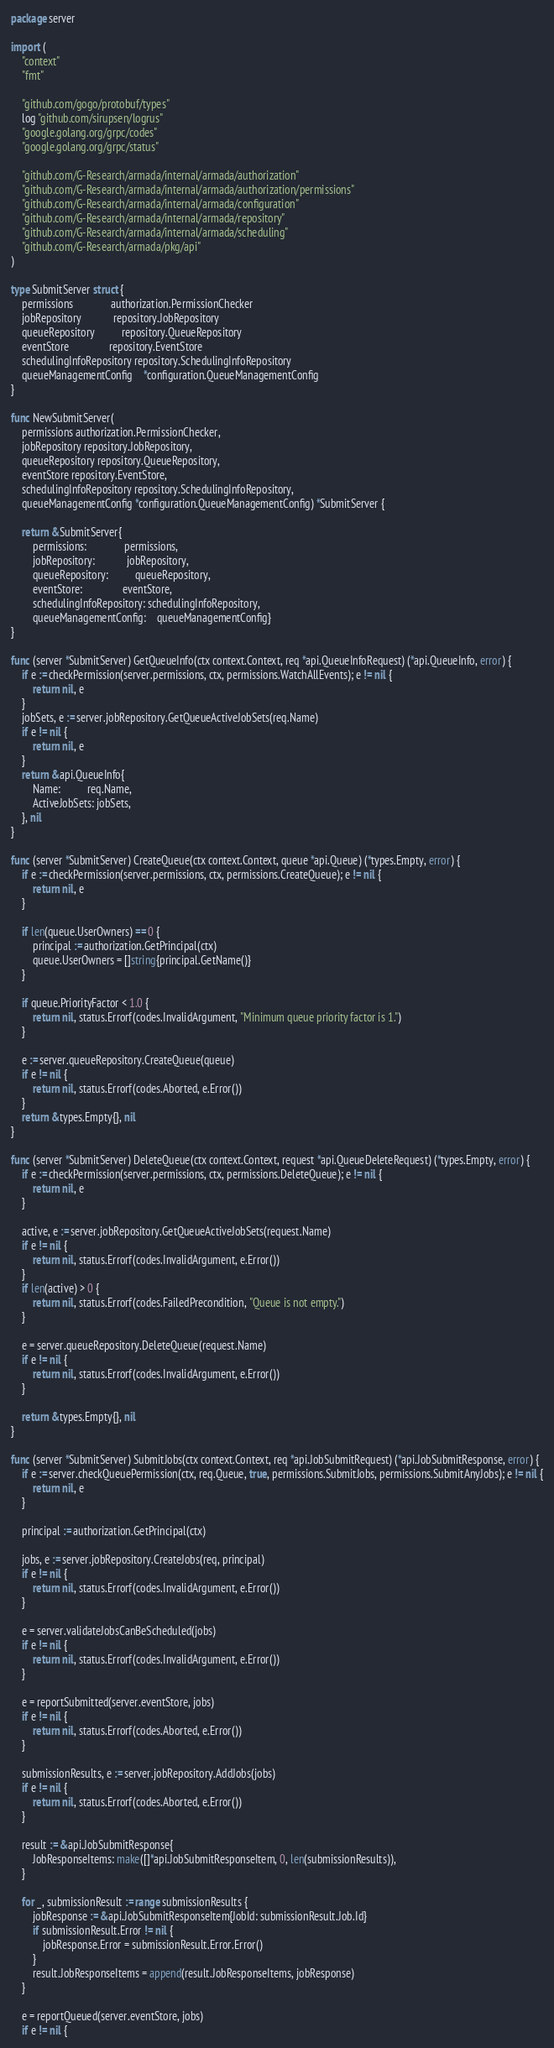<code> <loc_0><loc_0><loc_500><loc_500><_Go_>package server

import (
	"context"
	"fmt"

	"github.com/gogo/protobuf/types"
	log "github.com/sirupsen/logrus"
	"google.golang.org/grpc/codes"
	"google.golang.org/grpc/status"

	"github.com/G-Research/armada/internal/armada/authorization"
	"github.com/G-Research/armada/internal/armada/authorization/permissions"
	"github.com/G-Research/armada/internal/armada/configuration"
	"github.com/G-Research/armada/internal/armada/repository"
	"github.com/G-Research/armada/internal/armada/scheduling"
	"github.com/G-Research/armada/pkg/api"
)

type SubmitServer struct {
	permissions              authorization.PermissionChecker
	jobRepository            repository.JobRepository
	queueRepository          repository.QueueRepository
	eventStore               repository.EventStore
	schedulingInfoRepository repository.SchedulingInfoRepository
	queueManagementConfig    *configuration.QueueManagementConfig
}

func NewSubmitServer(
	permissions authorization.PermissionChecker,
	jobRepository repository.JobRepository,
	queueRepository repository.QueueRepository,
	eventStore repository.EventStore,
	schedulingInfoRepository repository.SchedulingInfoRepository,
	queueManagementConfig *configuration.QueueManagementConfig) *SubmitServer {

	return &SubmitServer{
		permissions:              permissions,
		jobRepository:            jobRepository,
		queueRepository:          queueRepository,
		eventStore:               eventStore,
		schedulingInfoRepository: schedulingInfoRepository,
		queueManagementConfig:    queueManagementConfig}
}

func (server *SubmitServer) GetQueueInfo(ctx context.Context, req *api.QueueInfoRequest) (*api.QueueInfo, error) {
	if e := checkPermission(server.permissions, ctx, permissions.WatchAllEvents); e != nil {
		return nil, e
	}
	jobSets, e := server.jobRepository.GetQueueActiveJobSets(req.Name)
	if e != nil {
		return nil, e
	}
	return &api.QueueInfo{
		Name:          req.Name,
		ActiveJobSets: jobSets,
	}, nil
}

func (server *SubmitServer) CreateQueue(ctx context.Context, queue *api.Queue) (*types.Empty, error) {
	if e := checkPermission(server.permissions, ctx, permissions.CreateQueue); e != nil {
		return nil, e
	}

	if len(queue.UserOwners) == 0 {
		principal := authorization.GetPrincipal(ctx)
		queue.UserOwners = []string{principal.GetName()}
	}

	if queue.PriorityFactor < 1.0 {
		return nil, status.Errorf(codes.InvalidArgument, "Minimum queue priority factor is 1.")
	}

	e := server.queueRepository.CreateQueue(queue)
	if e != nil {
		return nil, status.Errorf(codes.Aborted, e.Error())
	}
	return &types.Empty{}, nil
}

func (server *SubmitServer) DeleteQueue(ctx context.Context, request *api.QueueDeleteRequest) (*types.Empty, error) {
	if e := checkPermission(server.permissions, ctx, permissions.DeleteQueue); e != nil {
		return nil, e
	}

	active, e := server.jobRepository.GetQueueActiveJobSets(request.Name)
	if e != nil {
		return nil, status.Errorf(codes.InvalidArgument, e.Error())
	}
	if len(active) > 0 {
		return nil, status.Errorf(codes.FailedPrecondition, "Queue is not empty.")
	}

	e = server.queueRepository.DeleteQueue(request.Name)
	if e != nil {
		return nil, status.Errorf(codes.InvalidArgument, e.Error())
	}

	return &types.Empty{}, nil
}

func (server *SubmitServer) SubmitJobs(ctx context.Context, req *api.JobSubmitRequest) (*api.JobSubmitResponse, error) {
	if e := server.checkQueuePermission(ctx, req.Queue, true, permissions.SubmitJobs, permissions.SubmitAnyJobs); e != nil {
		return nil, e
	}

	principal := authorization.GetPrincipal(ctx)

	jobs, e := server.jobRepository.CreateJobs(req, principal)
	if e != nil {
		return nil, status.Errorf(codes.InvalidArgument, e.Error())
	}

	e = server.validateJobsCanBeScheduled(jobs)
	if e != nil {
		return nil, status.Errorf(codes.InvalidArgument, e.Error())
	}

	e = reportSubmitted(server.eventStore, jobs)
	if e != nil {
		return nil, status.Errorf(codes.Aborted, e.Error())
	}

	submissionResults, e := server.jobRepository.AddJobs(jobs)
	if e != nil {
		return nil, status.Errorf(codes.Aborted, e.Error())
	}

	result := &api.JobSubmitResponse{
		JobResponseItems: make([]*api.JobSubmitResponseItem, 0, len(submissionResults)),
	}

	for _, submissionResult := range submissionResults {
		jobResponse := &api.JobSubmitResponseItem{JobId: submissionResult.Job.Id}
		if submissionResult.Error != nil {
			jobResponse.Error = submissionResult.Error.Error()
		}
		result.JobResponseItems = append(result.JobResponseItems, jobResponse)
	}

	e = reportQueued(server.eventStore, jobs)
	if e != nil {</code> 